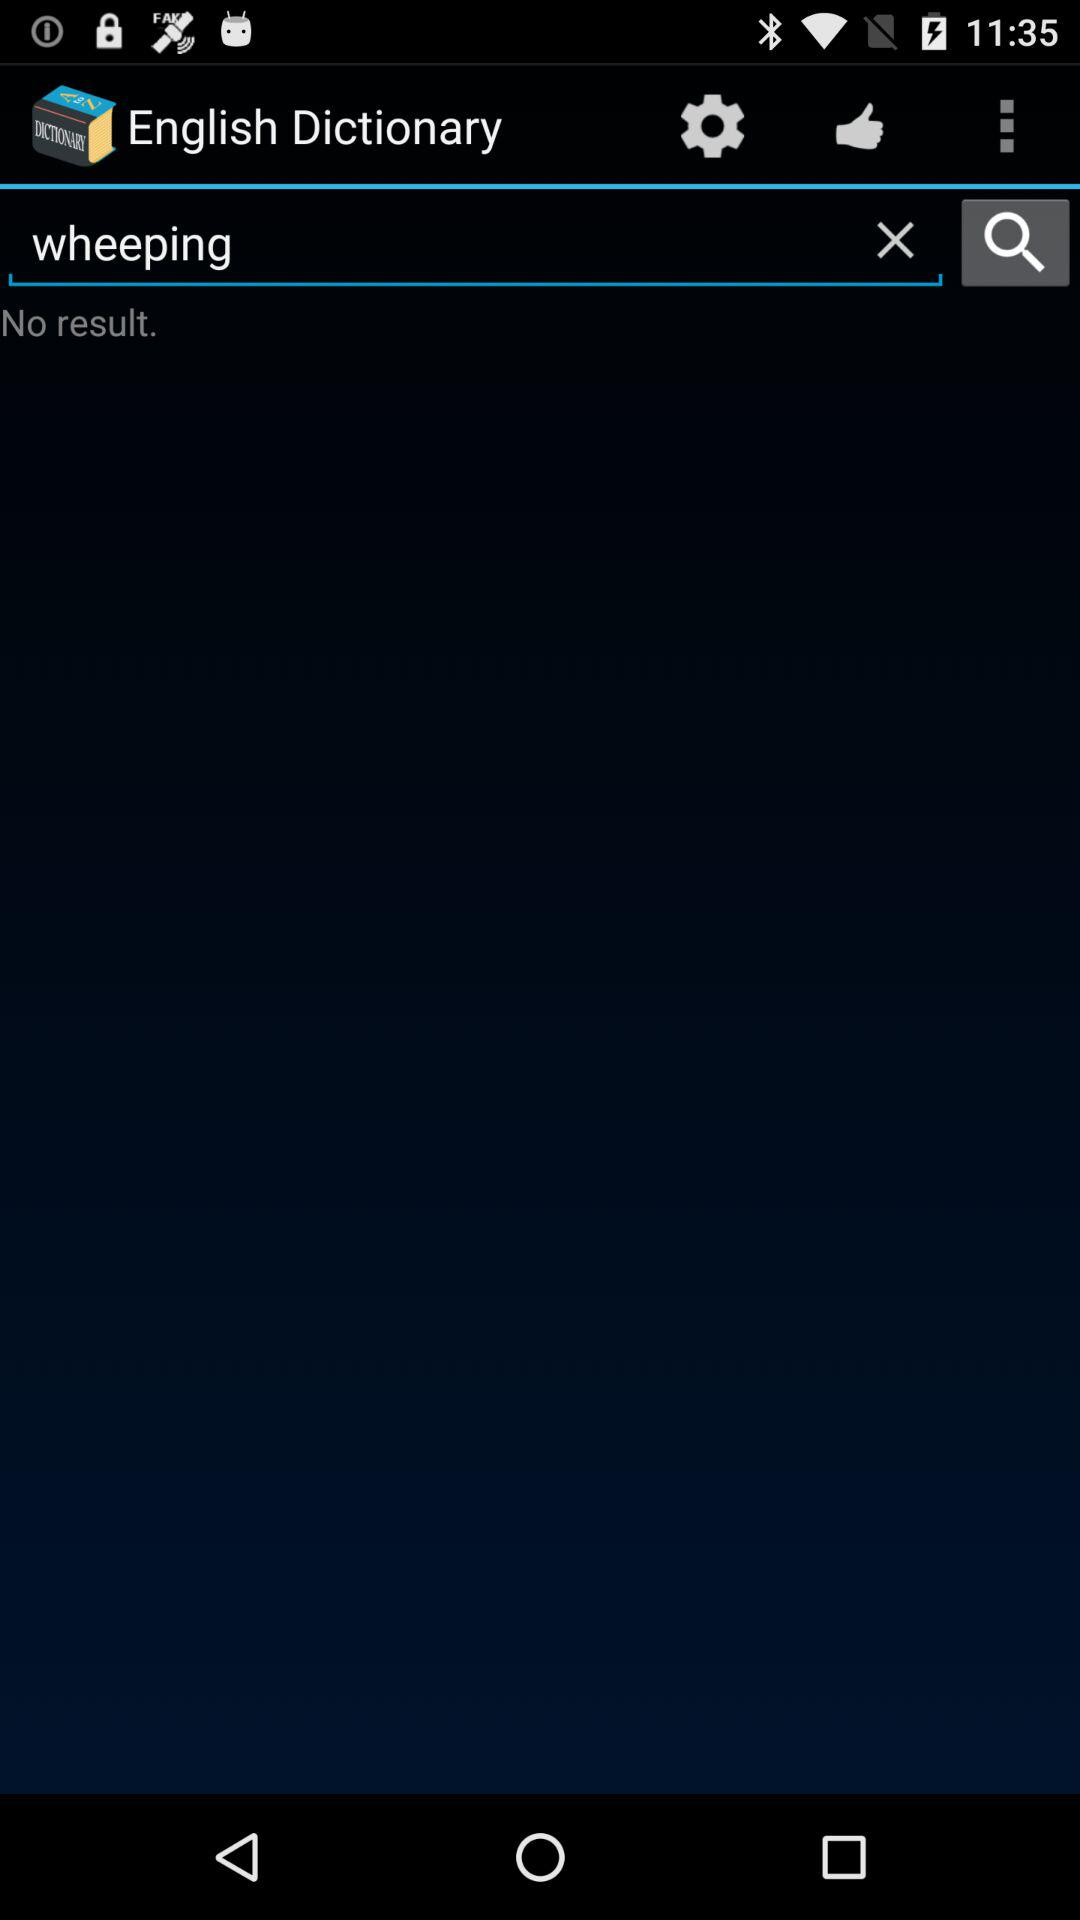Is there any result found? There is no found result. 